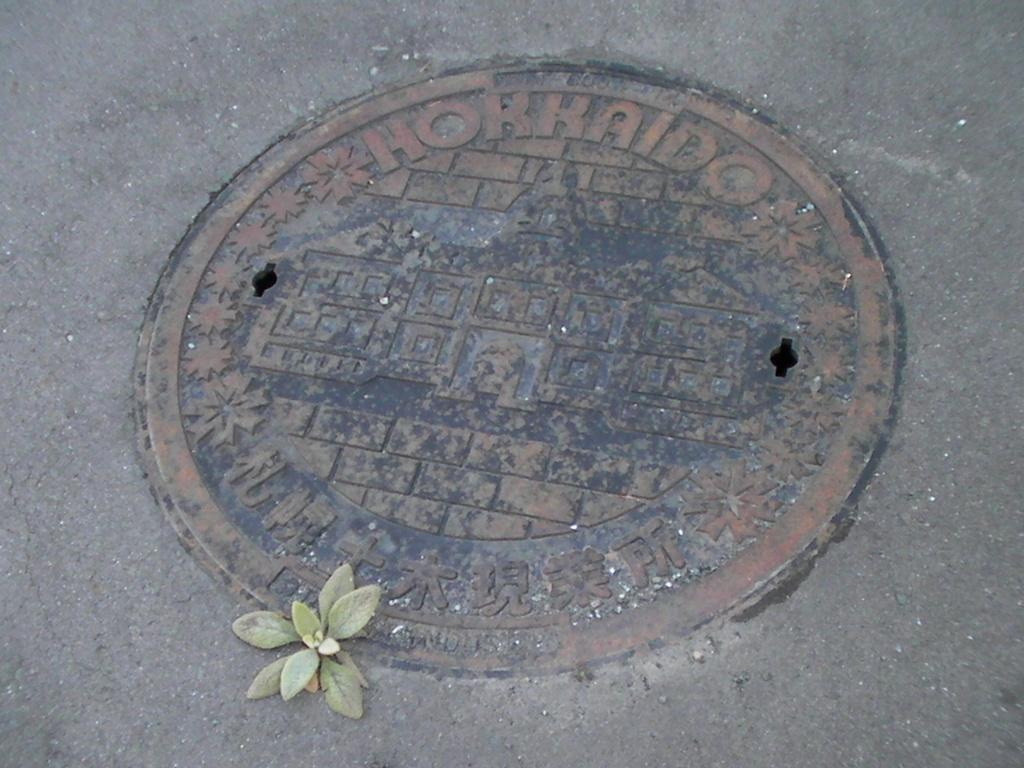What object is the main focus of the image? The main focus of the image is a drainage cap. Where is the drainage cap situated in relation to the road? The drainage cap is located between the road. How many passengers are visible in the image? There are no passengers present in the image; it only features a drainage cap between the road. What type of bag can be seen near the drainage cap? There is no bag present in the image; it only features a drainage cap between the road. 